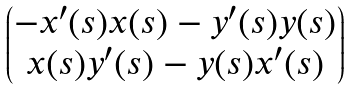<formula> <loc_0><loc_0><loc_500><loc_500>\begin{pmatrix} - x ^ { \prime } ( s ) x ( s ) - y ^ { \prime } ( s ) y ( s ) \\ x ( s ) y ^ { \prime } ( s ) - y ( s ) x ^ { \prime } ( s ) \end{pmatrix}</formula> 